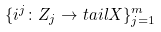Convert formula to latex. <formula><loc_0><loc_0><loc_500><loc_500>\{ i ^ { j } \colon Z _ { j } \rightarrow t a i l X \} _ { j = 1 } ^ { m }</formula> 